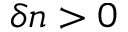<formula> <loc_0><loc_0><loc_500><loc_500>\delta n > 0</formula> 